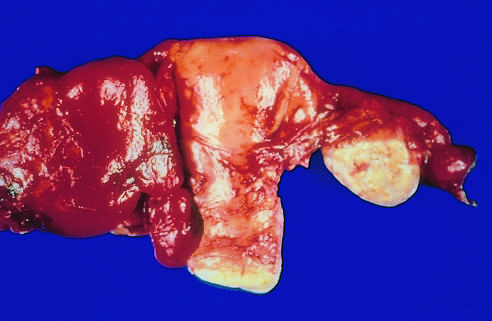what is adherent to the adjacent ovary on the other side?
Answer the question using a single word or phrase. The tube 